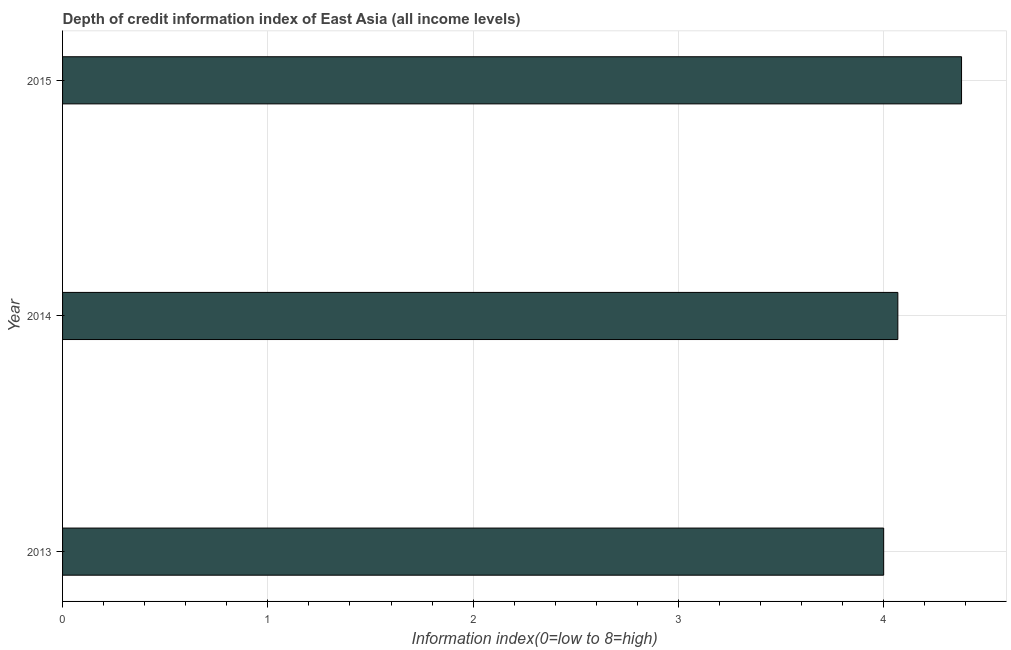Does the graph contain any zero values?
Offer a terse response. No. What is the title of the graph?
Your answer should be compact. Depth of credit information index of East Asia (all income levels). What is the label or title of the X-axis?
Provide a succinct answer. Information index(0=low to 8=high). What is the label or title of the Y-axis?
Give a very brief answer. Year. What is the depth of credit information index in 2014?
Your response must be concise. 4.07. Across all years, what is the maximum depth of credit information index?
Your answer should be very brief. 4.38. In which year was the depth of credit information index maximum?
Your answer should be very brief. 2015. In which year was the depth of credit information index minimum?
Offer a terse response. 2013. What is the sum of the depth of credit information index?
Your answer should be compact. 12.45. What is the difference between the depth of credit information index in 2013 and 2015?
Keep it short and to the point. -0.38. What is the average depth of credit information index per year?
Keep it short and to the point. 4.15. What is the median depth of credit information index?
Ensure brevity in your answer.  4.07. Is the difference between the depth of credit information index in 2013 and 2015 greater than the difference between any two years?
Ensure brevity in your answer.  Yes. What is the difference between the highest and the second highest depth of credit information index?
Ensure brevity in your answer.  0.31. What is the difference between the highest and the lowest depth of credit information index?
Ensure brevity in your answer.  0.38. How many bars are there?
Provide a short and direct response. 3. How many years are there in the graph?
Provide a short and direct response. 3. Are the values on the major ticks of X-axis written in scientific E-notation?
Ensure brevity in your answer.  No. What is the Information index(0=low to 8=high) of 2013?
Your answer should be very brief. 4. What is the Information index(0=low to 8=high) in 2014?
Make the answer very short. 4.07. What is the Information index(0=low to 8=high) of 2015?
Provide a succinct answer. 4.38. What is the difference between the Information index(0=low to 8=high) in 2013 and 2014?
Keep it short and to the point. -0.07. What is the difference between the Information index(0=low to 8=high) in 2013 and 2015?
Give a very brief answer. -0.38. What is the difference between the Information index(0=low to 8=high) in 2014 and 2015?
Provide a succinct answer. -0.31. What is the ratio of the Information index(0=low to 8=high) in 2014 to that in 2015?
Keep it short and to the point. 0.93. 